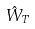Convert formula to latex. <formula><loc_0><loc_0><loc_500><loc_500>\hat { W } _ { T }</formula> 